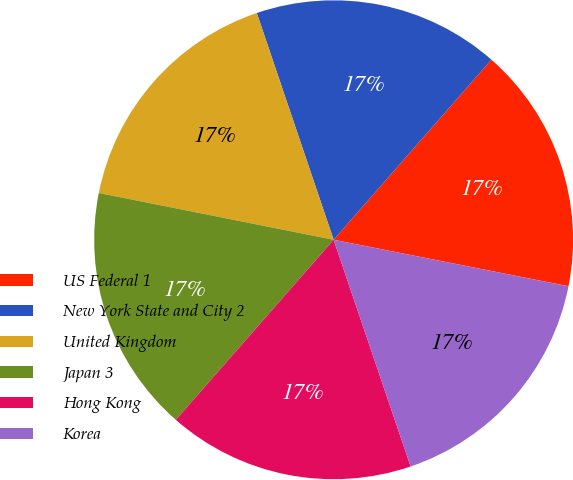<chart> <loc_0><loc_0><loc_500><loc_500><pie_chart><fcel>US Federal 1<fcel>New York State and City 2<fcel>United Kingdom<fcel>Japan 3<fcel>Hong Kong<fcel>Korea<nl><fcel>16.66%<fcel>16.65%<fcel>16.67%<fcel>16.68%<fcel>16.66%<fcel>16.68%<nl></chart> 